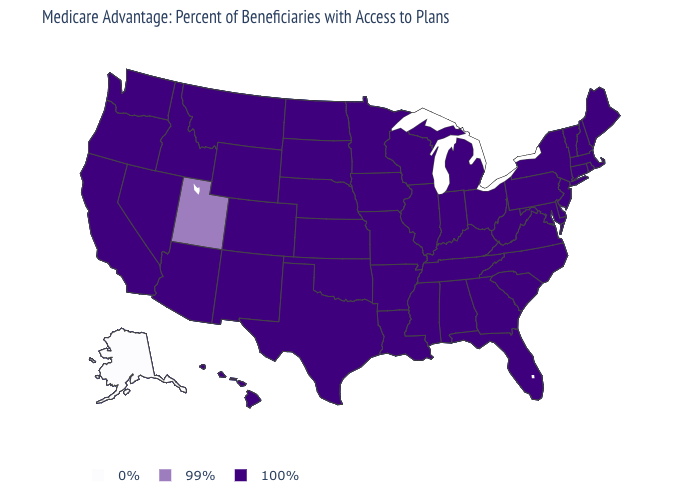What is the value of California?
Be succinct. 100%. What is the lowest value in the USA?
Give a very brief answer. 0%. Which states have the highest value in the USA?
Short answer required. Alabama, Arkansas, Arizona, California, Colorado, Connecticut, Delaware, Florida, Georgia, Hawaii, Iowa, Idaho, Illinois, Indiana, Kansas, Kentucky, Louisiana, Massachusetts, Maryland, Maine, Michigan, Minnesota, Missouri, Mississippi, Montana, North Carolina, North Dakota, Nebraska, New Hampshire, New Jersey, New Mexico, Nevada, New York, Ohio, Oklahoma, Oregon, Pennsylvania, Rhode Island, South Carolina, South Dakota, Tennessee, Texas, Virginia, Vermont, Washington, Wisconsin, West Virginia, Wyoming. What is the value of Montana?
Answer briefly. 100%. Name the states that have a value in the range 99%?
Answer briefly. Utah. Name the states that have a value in the range 99%?
Keep it brief. Utah. Name the states that have a value in the range 0%?
Be succinct. Alaska. What is the highest value in the Northeast ?
Write a very short answer. 100%. What is the highest value in the Northeast ?
Be succinct. 100%. Name the states that have a value in the range 0%?
Write a very short answer. Alaska. Does Indiana have a lower value than Kansas?
Answer briefly. No. Which states hav the highest value in the Northeast?
Keep it brief. Connecticut, Massachusetts, Maine, New Hampshire, New Jersey, New York, Pennsylvania, Rhode Island, Vermont. Among the states that border Wyoming , does Utah have the highest value?
Write a very short answer. No. How many symbols are there in the legend?
Concise answer only. 3. Which states hav the highest value in the MidWest?
Write a very short answer. Iowa, Illinois, Indiana, Kansas, Michigan, Minnesota, Missouri, North Dakota, Nebraska, Ohio, South Dakota, Wisconsin. 